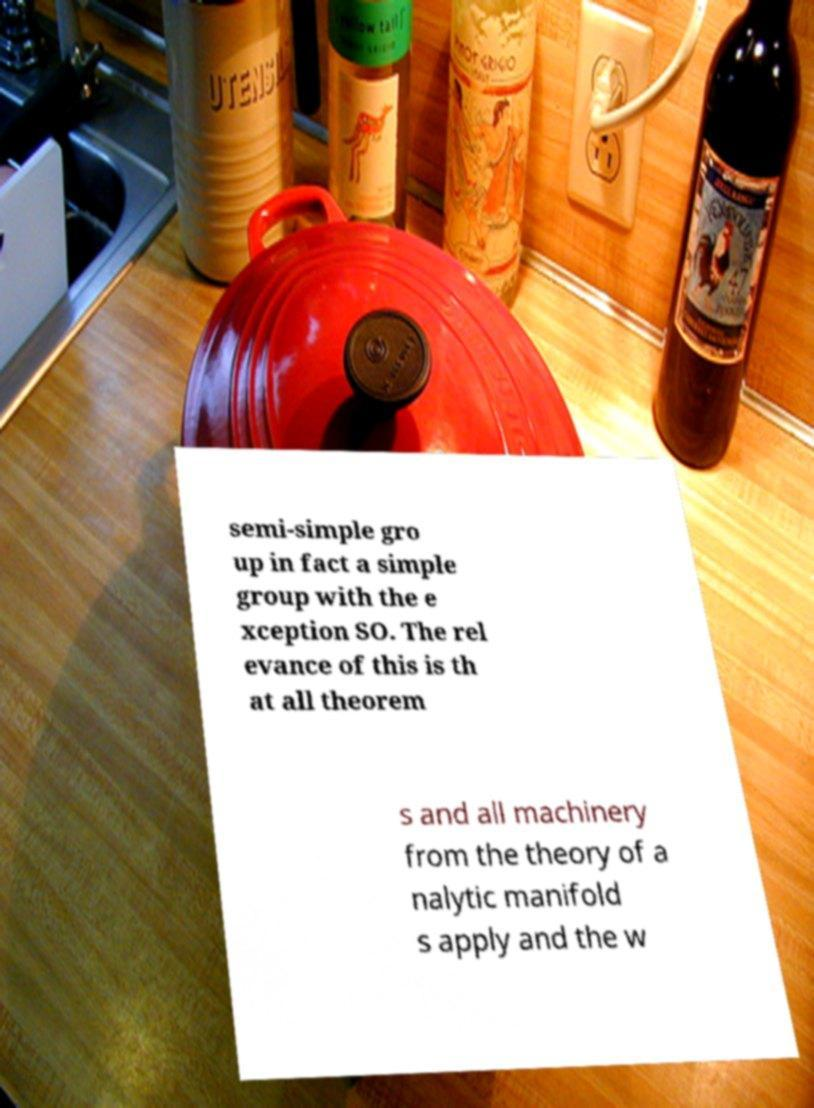For documentation purposes, I need the text within this image transcribed. Could you provide that? semi-simple gro up in fact a simple group with the e xception SO. The rel evance of this is th at all theorem s and all machinery from the theory of a nalytic manifold s apply and the w 